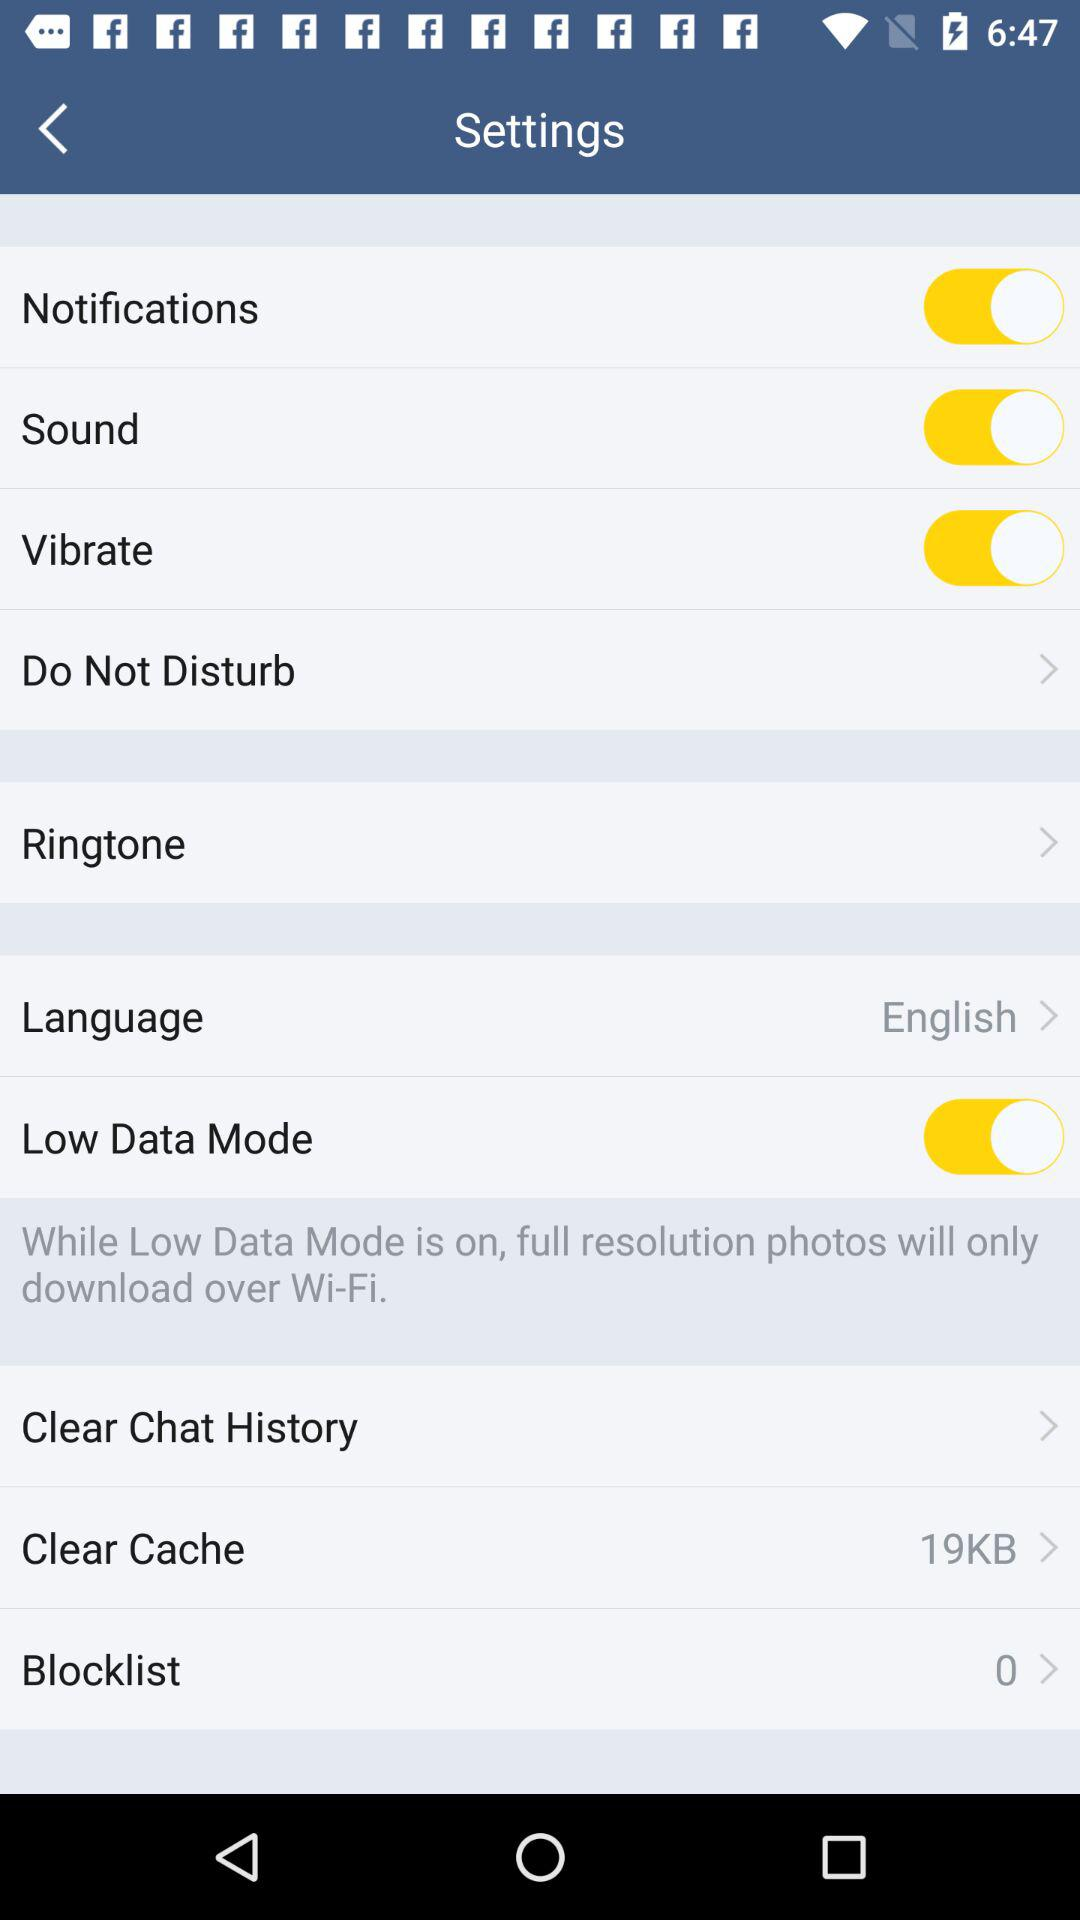How many kilobytes are mentioned in the clear cache? The mentioned kilobytes are 19. 